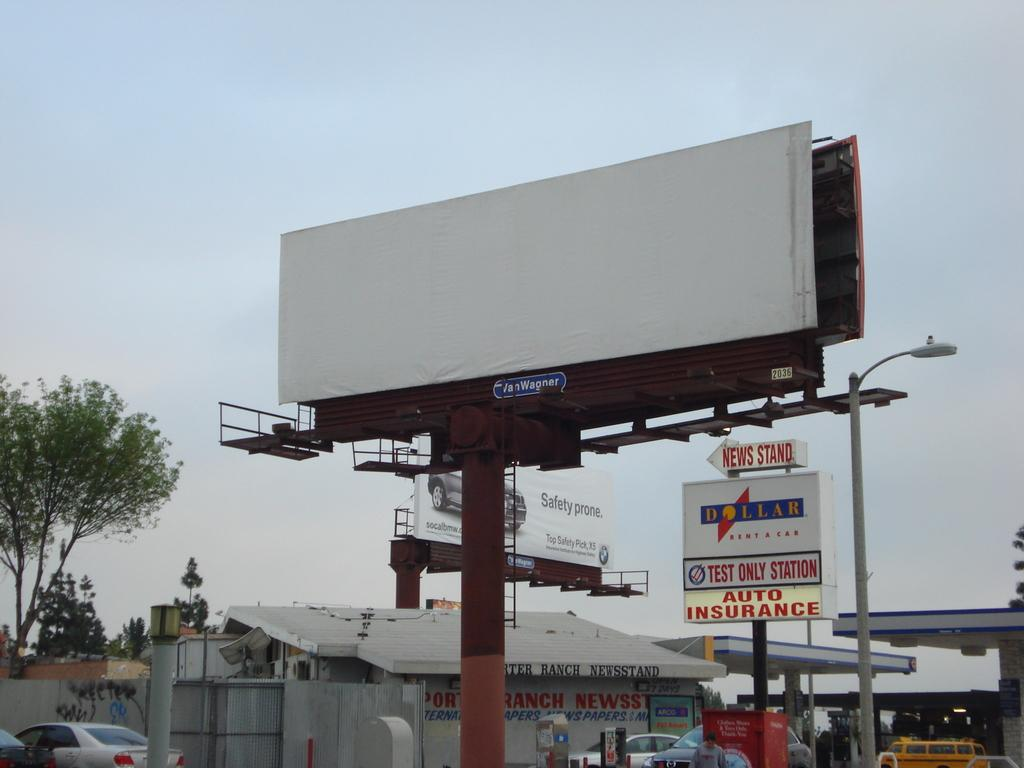Provide a one-sentence caption for the provided image. An arrow sign is pointed left to the news stand. 